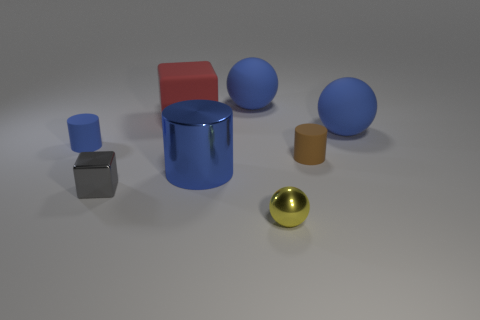Add 7 big cubes. How many big cubes are left? 8 Add 3 matte balls. How many matte balls exist? 5 Add 2 blue rubber cylinders. How many objects exist? 10 Subtract all brown cylinders. How many cylinders are left? 2 Subtract all matte spheres. How many spheres are left? 1 Subtract 0 red balls. How many objects are left? 8 Subtract all balls. How many objects are left? 5 Subtract 1 spheres. How many spheres are left? 2 Subtract all yellow cylinders. Subtract all purple spheres. How many cylinders are left? 3 Subtract all brown cylinders. How many green balls are left? 0 